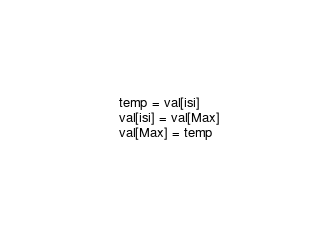Convert code to text. <code><loc_0><loc_0><loc_500><loc_500><_Python_>       temp = val[isi]
       val[isi] = val[Max]
       val[Max] = temp</code> 